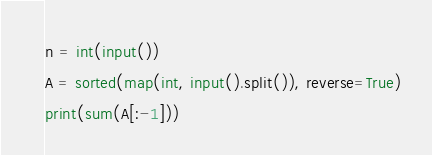Convert code to text. <code><loc_0><loc_0><loc_500><loc_500><_Python_>n = int(input())
A = sorted(map(int, input().split()), reverse=True)
print(sum(A[:-1]))</code> 